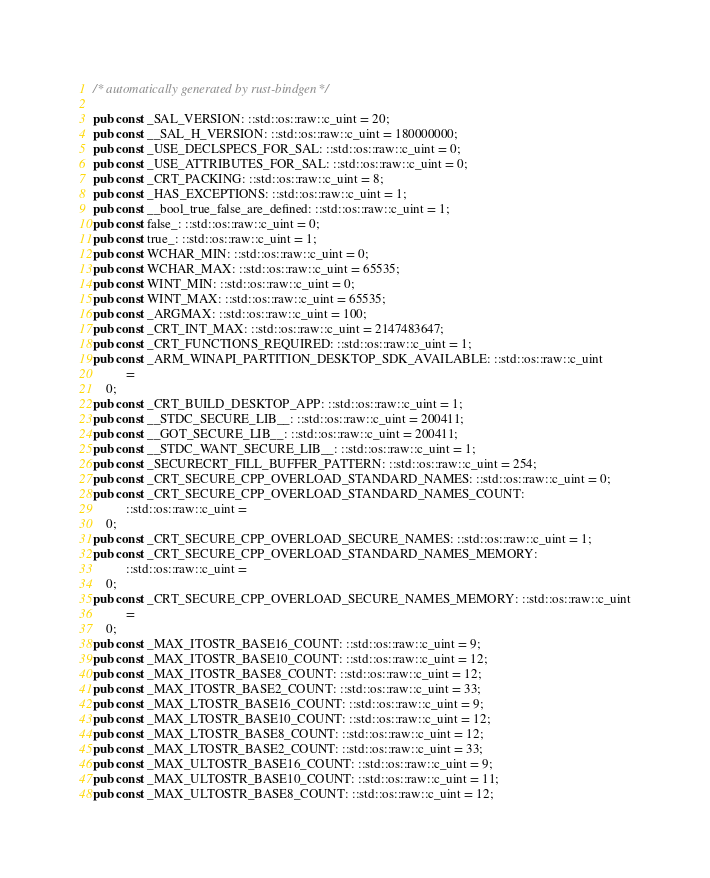<code> <loc_0><loc_0><loc_500><loc_500><_Rust_>/* automatically generated by rust-bindgen */

pub const _SAL_VERSION: ::std::os::raw::c_uint = 20;
pub const __SAL_H_VERSION: ::std::os::raw::c_uint = 180000000;
pub const _USE_DECLSPECS_FOR_SAL: ::std::os::raw::c_uint = 0;
pub const _USE_ATTRIBUTES_FOR_SAL: ::std::os::raw::c_uint = 0;
pub const _CRT_PACKING: ::std::os::raw::c_uint = 8;
pub const _HAS_EXCEPTIONS: ::std::os::raw::c_uint = 1;
pub const __bool_true_false_are_defined: ::std::os::raw::c_uint = 1;
pub const false_: ::std::os::raw::c_uint = 0;
pub const true_: ::std::os::raw::c_uint = 1;
pub const WCHAR_MIN: ::std::os::raw::c_uint = 0;
pub const WCHAR_MAX: ::std::os::raw::c_uint = 65535;
pub const WINT_MIN: ::std::os::raw::c_uint = 0;
pub const WINT_MAX: ::std::os::raw::c_uint = 65535;
pub const _ARGMAX: ::std::os::raw::c_uint = 100;
pub const _CRT_INT_MAX: ::std::os::raw::c_uint = 2147483647;
pub const _CRT_FUNCTIONS_REQUIRED: ::std::os::raw::c_uint = 1;
pub const _ARM_WINAPI_PARTITION_DESKTOP_SDK_AVAILABLE: ::std::os::raw::c_uint
          =
    0;
pub const _CRT_BUILD_DESKTOP_APP: ::std::os::raw::c_uint = 1;
pub const __STDC_SECURE_LIB__: ::std::os::raw::c_uint = 200411;
pub const __GOT_SECURE_LIB__: ::std::os::raw::c_uint = 200411;
pub const __STDC_WANT_SECURE_LIB__: ::std::os::raw::c_uint = 1;
pub const _SECURECRT_FILL_BUFFER_PATTERN: ::std::os::raw::c_uint = 254;
pub const _CRT_SECURE_CPP_OVERLOAD_STANDARD_NAMES: ::std::os::raw::c_uint = 0;
pub const _CRT_SECURE_CPP_OVERLOAD_STANDARD_NAMES_COUNT:
          ::std::os::raw::c_uint =
    0;
pub const _CRT_SECURE_CPP_OVERLOAD_SECURE_NAMES: ::std::os::raw::c_uint = 1;
pub const _CRT_SECURE_CPP_OVERLOAD_STANDARD_NAMES_MEMORY:
          ::std::os::raw::c_uint =
    0;
pub const _CRT_SECURE_CPP_OVERLOAD_SECURE_NAMES_MEMORY: ::std::os::raw::c_uint
          =
    0;
pub const _MAX_ITOSTR_BASE16_COUNT: ::std::os::raw::c_uint = 9;
pub const _MAX_ITOSTR_BASE10_COUNT: ::std::os::raw::c_uint = 12;
pub const _MAX_ITOSTR_BASE8_COUNT: ::std::os::raw::c_uint = 12;
pub const _MAX_ITOSTR_BASE2_COUNT: ::std::os::raw::c_uint = 33;
pub const _MAX_LTOSTR_BASE16_COUNT: ::std::os::raw::c_uint = 9;
pub const _MAX_LTOSTR_BASE10_COUNT: ::std::os::raw::c_uint = 12;
pub const _MAX_LTOSTR_BASE8_COUNT: ::std::os::raw::c_uint = 12;
pub const _MAX_LTOSTR_BASE2_COUNT: ::std::os::raw::c_uint = 33;
pub const _MAX_ULTOSTR_BASE16_COUNT: ::std::os::raw::c_uint = 9;
pub const _MAX_ULTOSTR_BASE10_COUNT: ::std::os::raw::c_uint = 11;
pub const _MAX_ULTOSTR_BASE8_COUNT: ::std::os::raw::c_uint = 12;</code> 